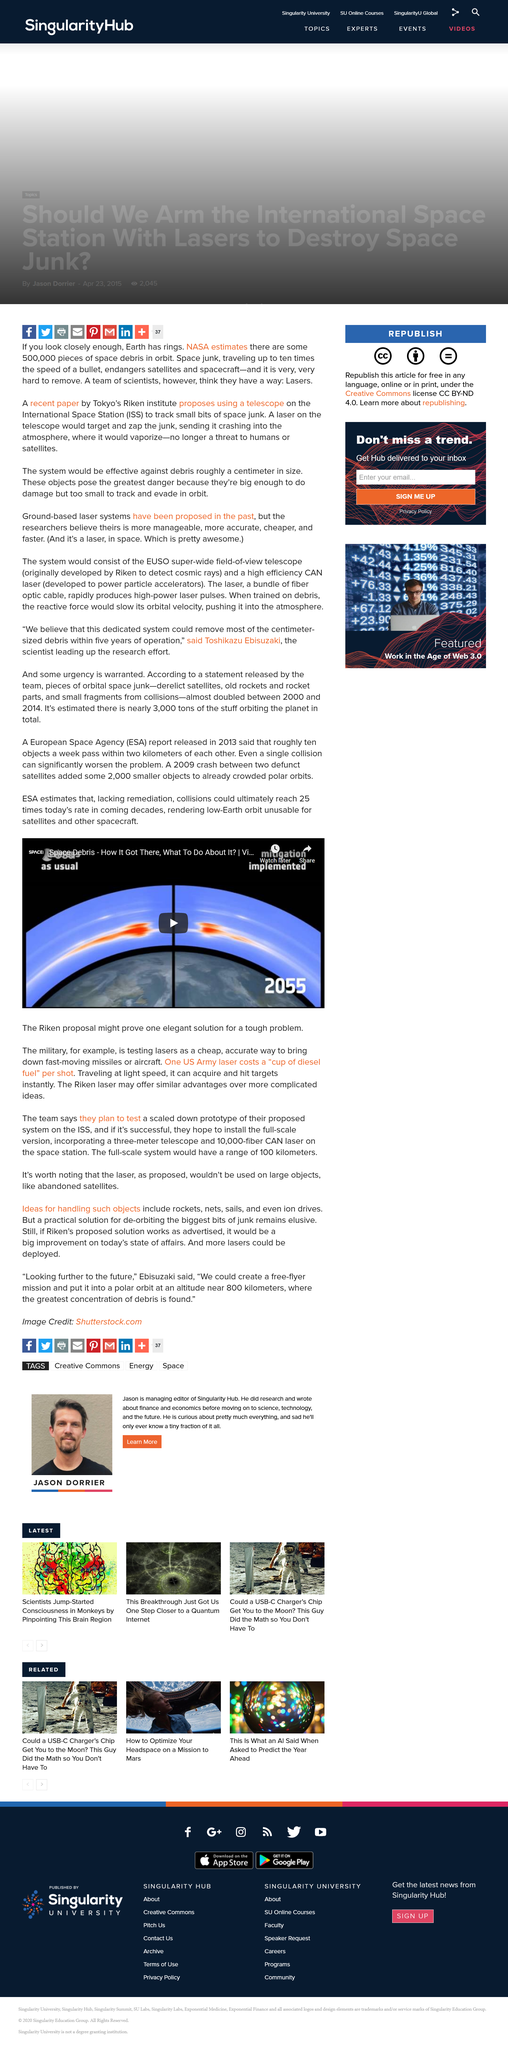Point out several critical features in this image. The Riken Laser is a potential solution to the space debris problem that may offer advantages over more complex approaches. The military is currently conducting experiments on the utilization of lasers as an affordable and precise method of neutralizing fast-moving missiles and aircraft. The acronym ESA stands for the European Space Agency. 